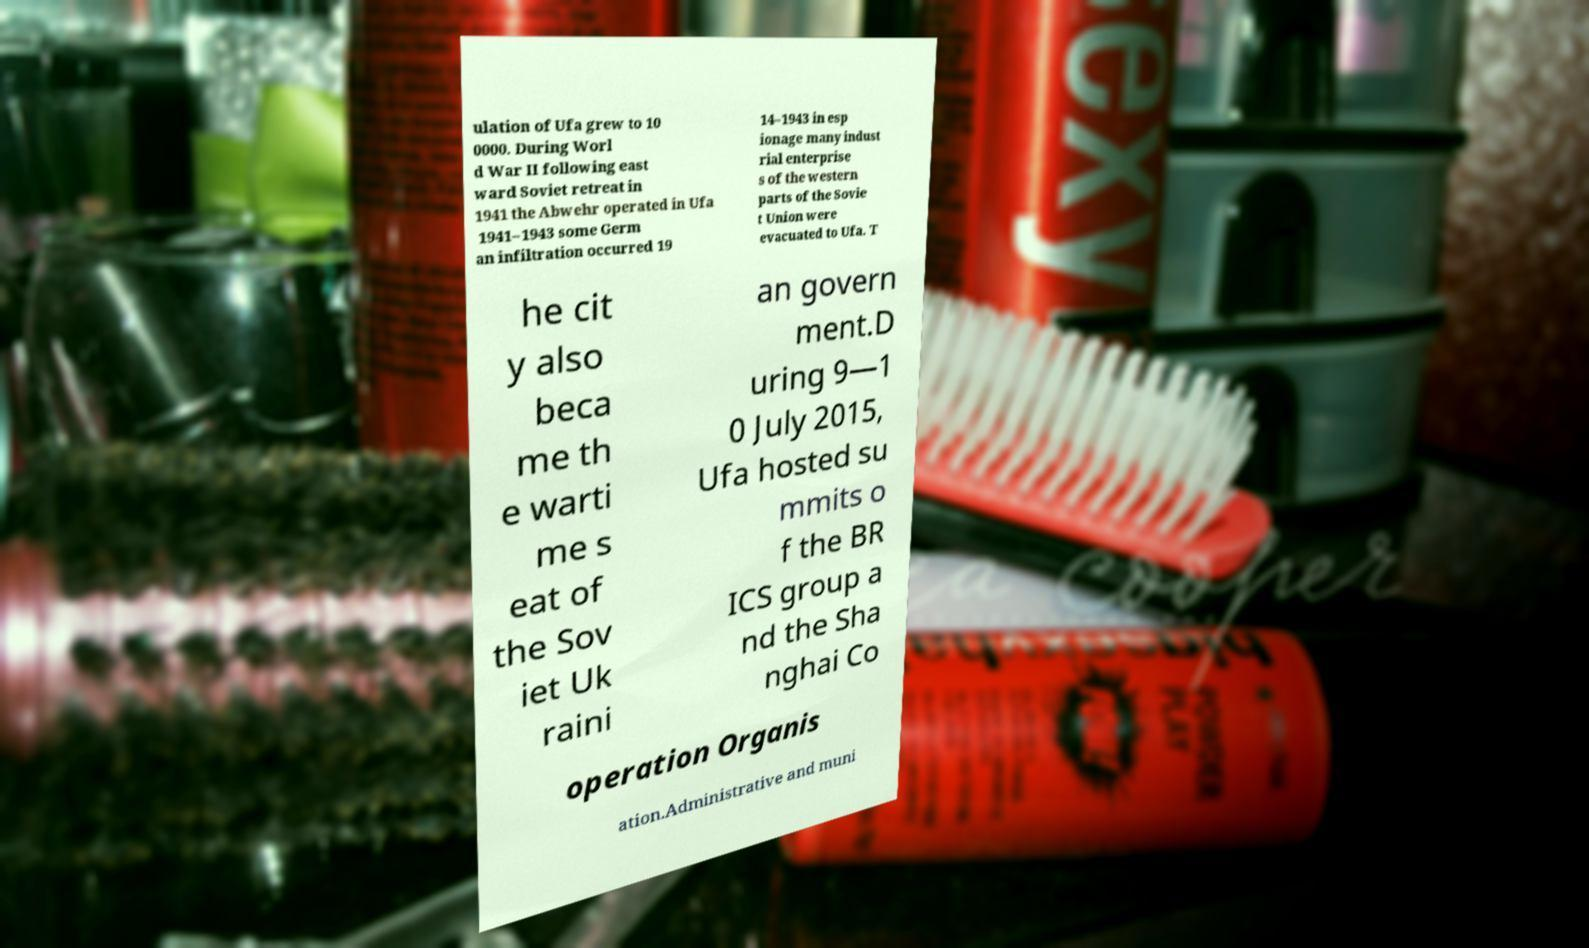For documentation purposes, I need the text within this image transcribed. Could you provide that? ulation of Ufa grew to 10 0000. During Worl d War II following east ward Soviet retreat in 1941 the Abwehr operated in Ufa 1941–1943 some Germ an infiltration occurred 19 14–1943 in esp ionage many indust rial enterprise s of the western parts of the Sovie t Union were evacuated to Ufa. T he cit y also beca me th e warti me s eat of the Sov iet Uk raini an govern ment.D uring 9—1 0 July 2015, Ufa hosted su mmits o f the BR ICS group a nd the Sha nghai Co operation Organis ation.Administrative and muni 